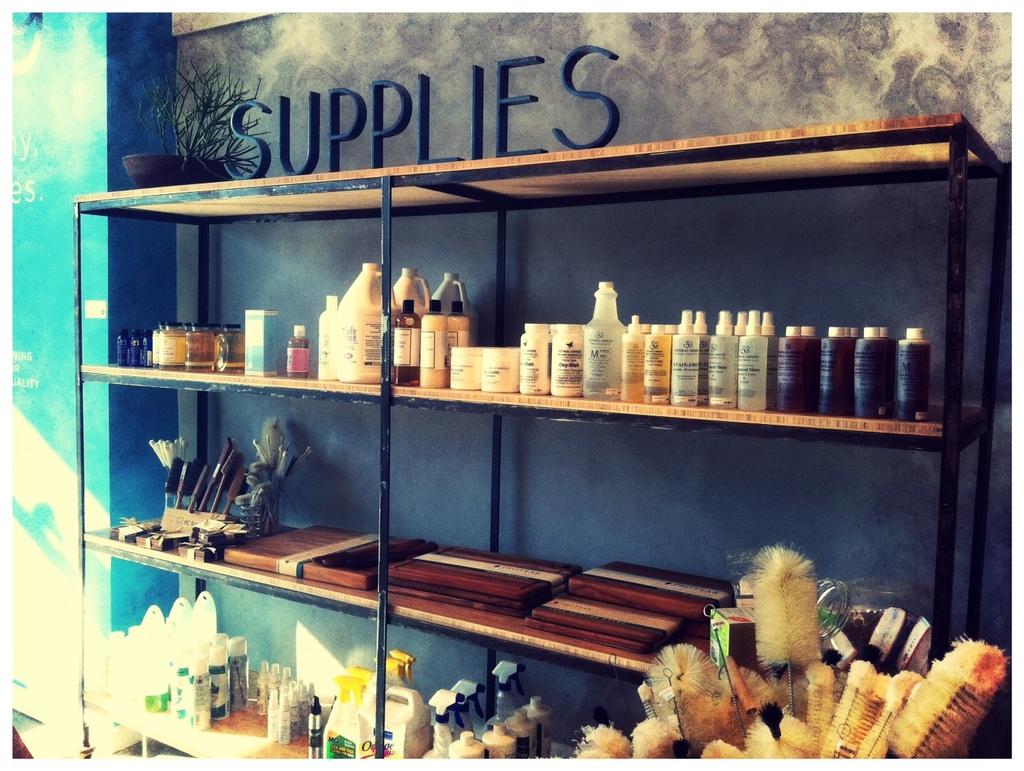What does it say on the top of the shelf?
Offer a terse response. Supplies. 